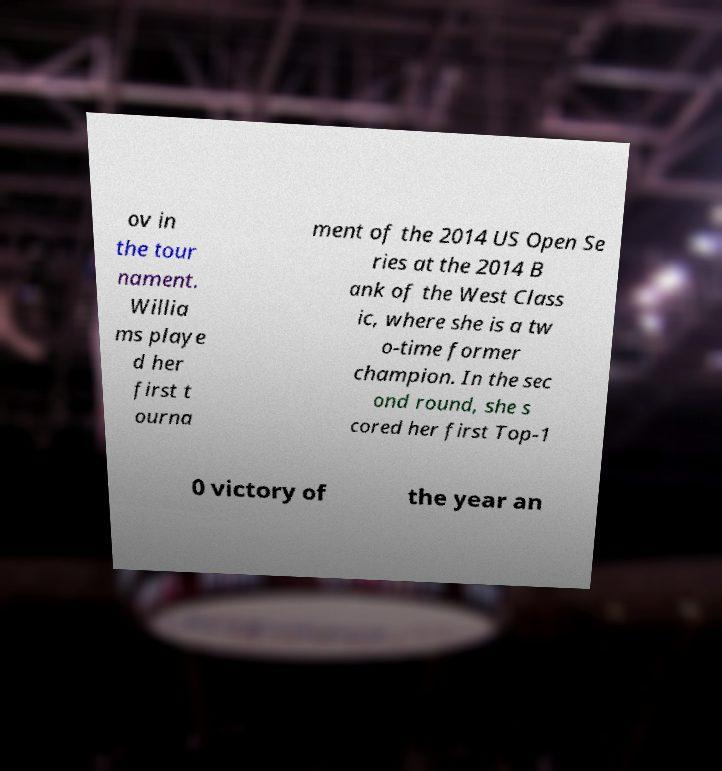What messages or text are displayed in this image? I need them in a readable, typed format. ov in the tour nament. Willia ms playe d her first t ourna ment of the 2014 US Open Se ries at the 2014 B ank of the West Class ic, where she is a tw o-time former champion. In the sec ond round, she s cored her first Top-1 0 victory of the year an 